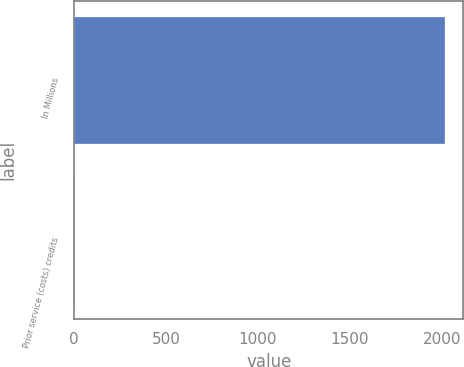Convert chart to OTSL. <chart><loc_0><loc_0><loc_500><loc_500><bar_chart><fcel>In Millions<fcel>Prior service (costs) credits<nl><fcel>2017<fcel>3.9<nl></chart> 